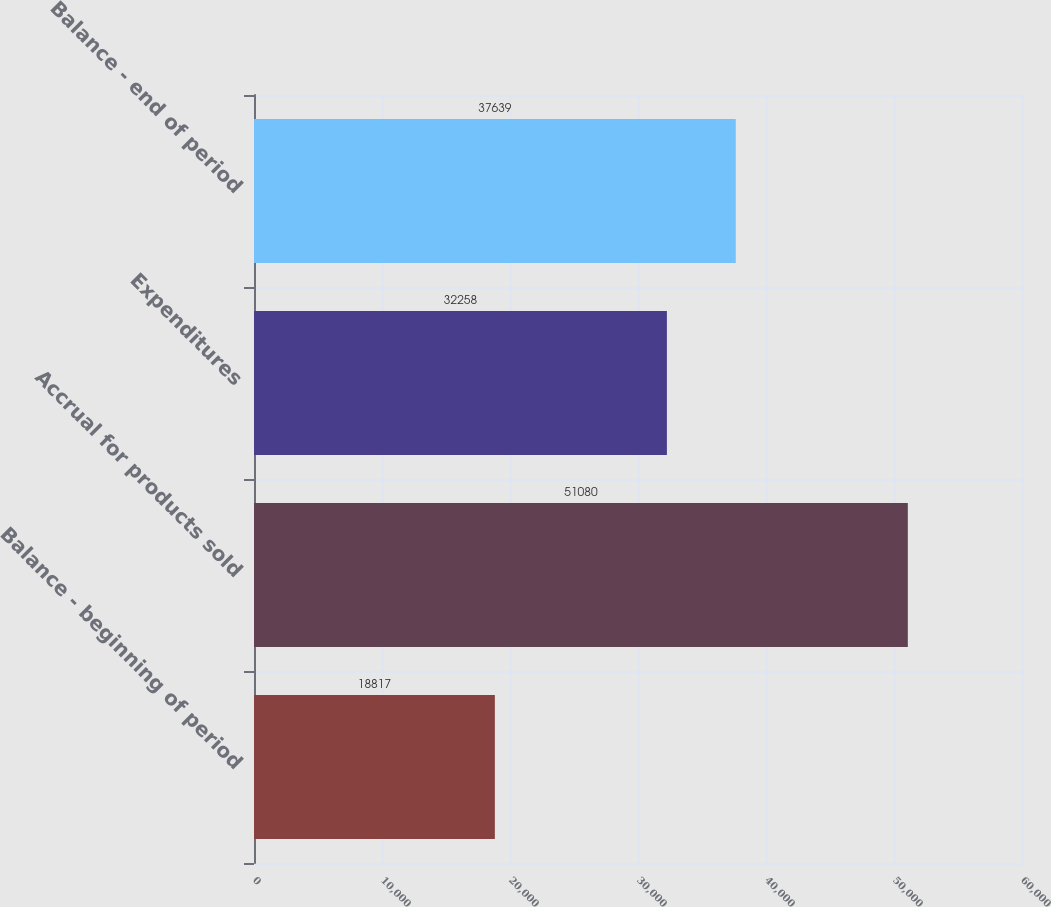Convert chart to OTSL. <chart><loc_0><loc_0><loc_500><loc_500><bar_chart><fcel>Balance - beginning of period<fcel>Accrual for products sold<fcel>Expenditures<fcel>Balance - end of period<nl><fcel>18817<fcel>51080<fcel>32258<fcel>37639<nl></chart> 